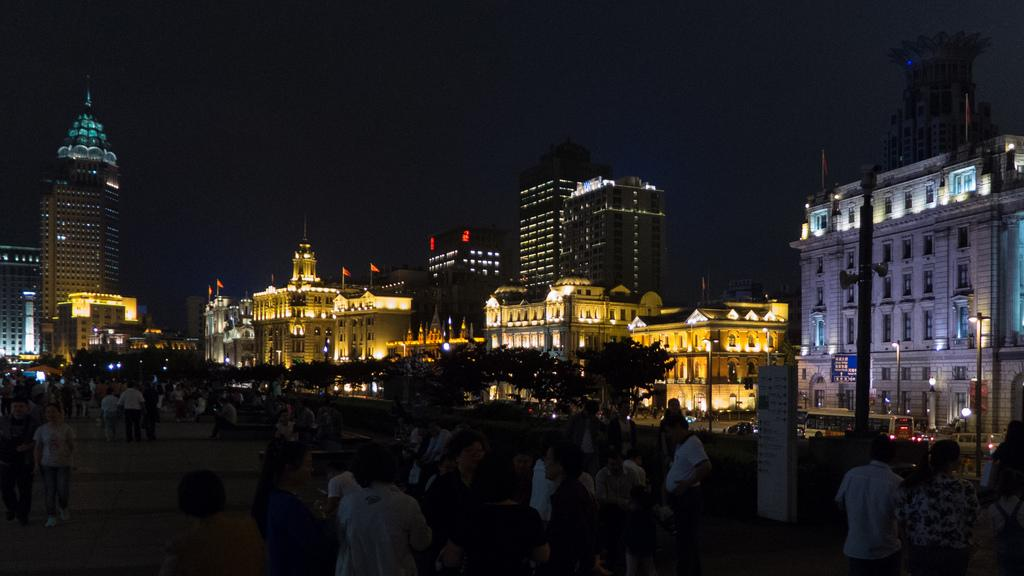What time of day is depicted in the image? The image depicts a night view. What structures can be seen in the image? There are buildings visible in the image. What can be seen in the sky in the image? The sky is visible in the image. What type of vegetation is present in the image? Trees are present in the image. Are there any people visible in the image? Yes, there are persons in the image. What type of form can be seen in the image, and where is it located? There is no specific form mentioned in the facts, so we cannot answer this question. Is there any dirt visible in the image? The facts do not mention dirt, so we cannot determine if it is present in the image. Can you tell me how many donkeys are in the image? There is no mention of donkeys in the facts, so we cannot determine if they are present in the image. 